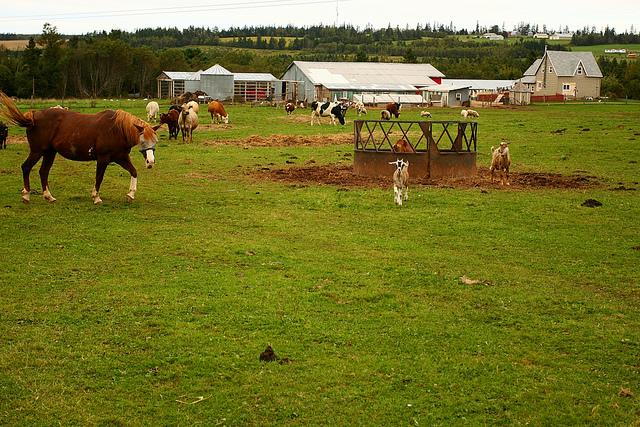How many eyes does the animal on the left have? two 